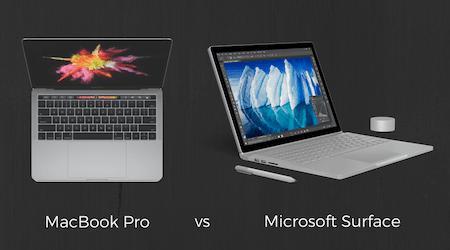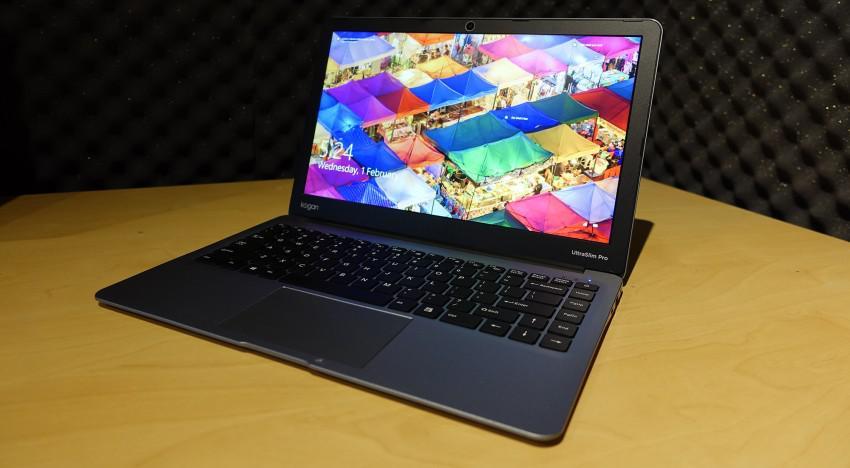The first image is the image on the left, the second image is the image on the right. For the images shown, is this caption "There are two screens in one of the images." true? Answer yes or no. Yes. The first image is the image on the left, the second image is the image on the right. Analyze the images presented: Is the assertion "One image shows an open laptop angled facing leftward, and the other image includes a head-on aerial view of an open laptop." valid? Answer yes or no. Yes. 